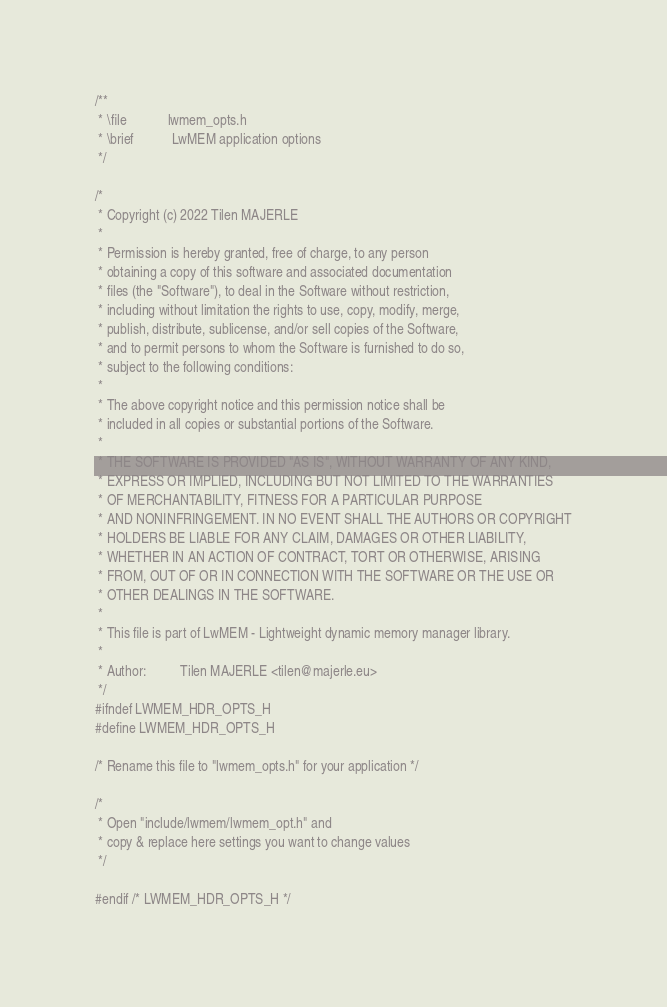Convert code to text. <code><loc_0><loc_0><loc_500><loc_500><_C_>/**
 * \file            lwmem_opts.h
 * \brief           LwMEM application options
 */

/*
 * Copyright (c) 2022 Tilen MAJERLE
 *
 * Permission is hereby granted, free of charge, to any person
 * obtaining a copy of this software and associated documentation
 * files (the "Software"), to deal in the Software without restriction,
 * including without limitation the rights to use, copy, modify, merge,
 * publish, distribute, sublicense, and/or sell copies of the Software,
 * and to permit persons to whom the Software is furnished to do so,
 * subject to the following conditions:
 *
 * The above copyright notice and this permission notice shall be
 * included in all copies or substantial portions of the Software.
 *
 * THE SOFTWARE IS PROVIDED "AS IS", WITHOUT WARRANTY OF ANY KIND,
 * EXPRESS OR IMPLIED, INCLUDING BUT NOT LIMITED TO THE WARRANTIES
 * OF MERCHANTABILITY, FITNESS FOR A PARTICULAR PURPOSE
 * AND NONINFRINGEMENT. IN NO EVENT SHALL THE AUTHORS OR COPYRIGHT
 * HOLDERS BE LIABLE FOR ANY CLAIM, DAMAGES OR OTHER LIABILITY,
 * WHETHER IN AN ACTION OF CONTRACT, TORT OR OTHERWISE, ARISING
 * FROM, OUT OF OR IN CONNECTION WITH THE SOFTWARE OR THE USE OR
 * OTHER DEALINGS IN THE SOFTWARE.
 *
 * This file is part of LwMEM - Lightweight dynamic memory manager library.
 *
 * Author:          Tilen MAJERLE <tilen@majerle.eu>
 */
#ifndef LWMEM_HDR_OPTS_H
#define LWMEM_HDR_OPTS_H

/* Rename this file to "lwmem_opts.h" for your application */

/*
 * Open "include/lwmem/lwmem_opt.h" and
 * copy & replace here settings you want to change values
 */

#endif /* LWMEM_HDR_OPTS_H */
</code> 